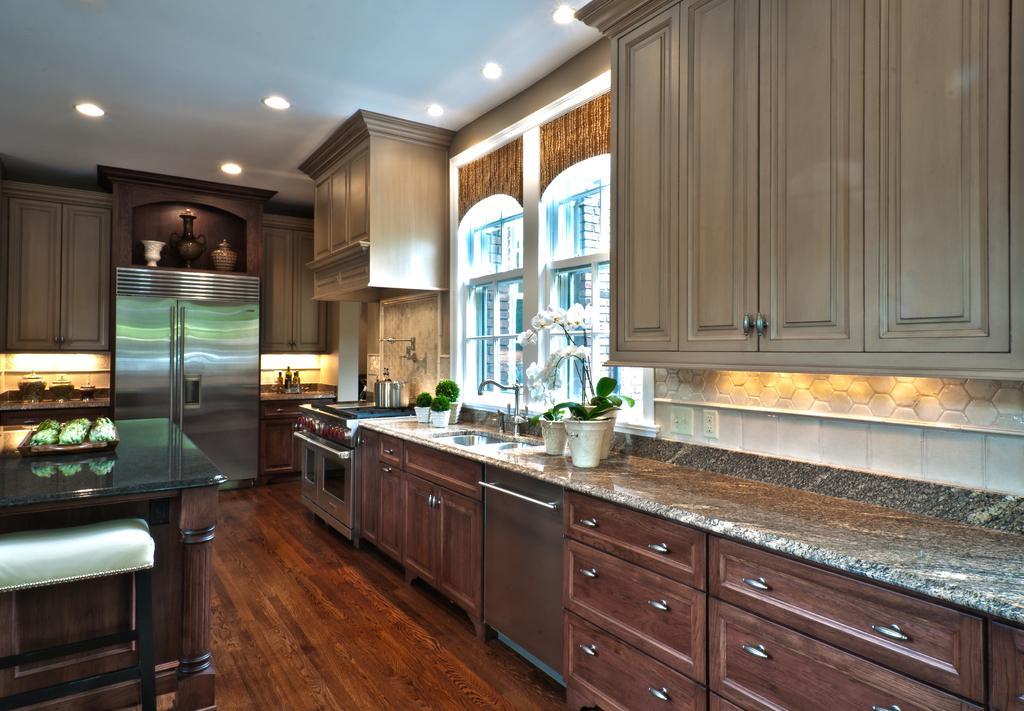How would you summarize this image in a sentence or two? In this picture I can see the inside view of a room and on the right side of this picture I can see the counter top on which there are plants in the pots and I can see a sink. I can also see the drawers and the cabinets and I see the windows. In the background I see few more cabinets, a refrigerator on which there are 3 pots and I see few more things. On the top of this picture I can see the ceiling on which there are lights. 